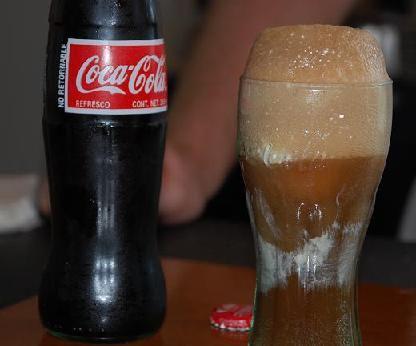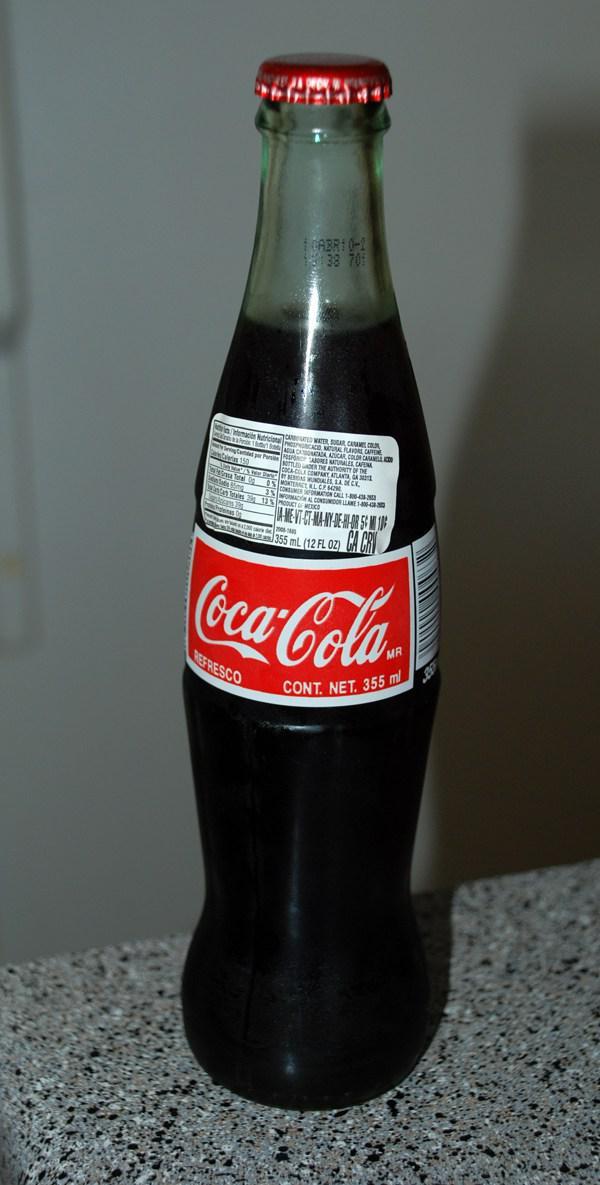The first image is the image on the left, the second image is the image on the right. Considering the images on both sides, is "One image includes at least one candle with a wick in an upright glass soda bottle with a red label and its neck cut off." valid? Answer yes or no. No. The first image is the image on the left, the second image is the image on the right. Examine the images to the left and right. Is the description "The left and right image contains the same number of glass containers shaped like a bottle." accurate? Answer yes or no. Yes. 